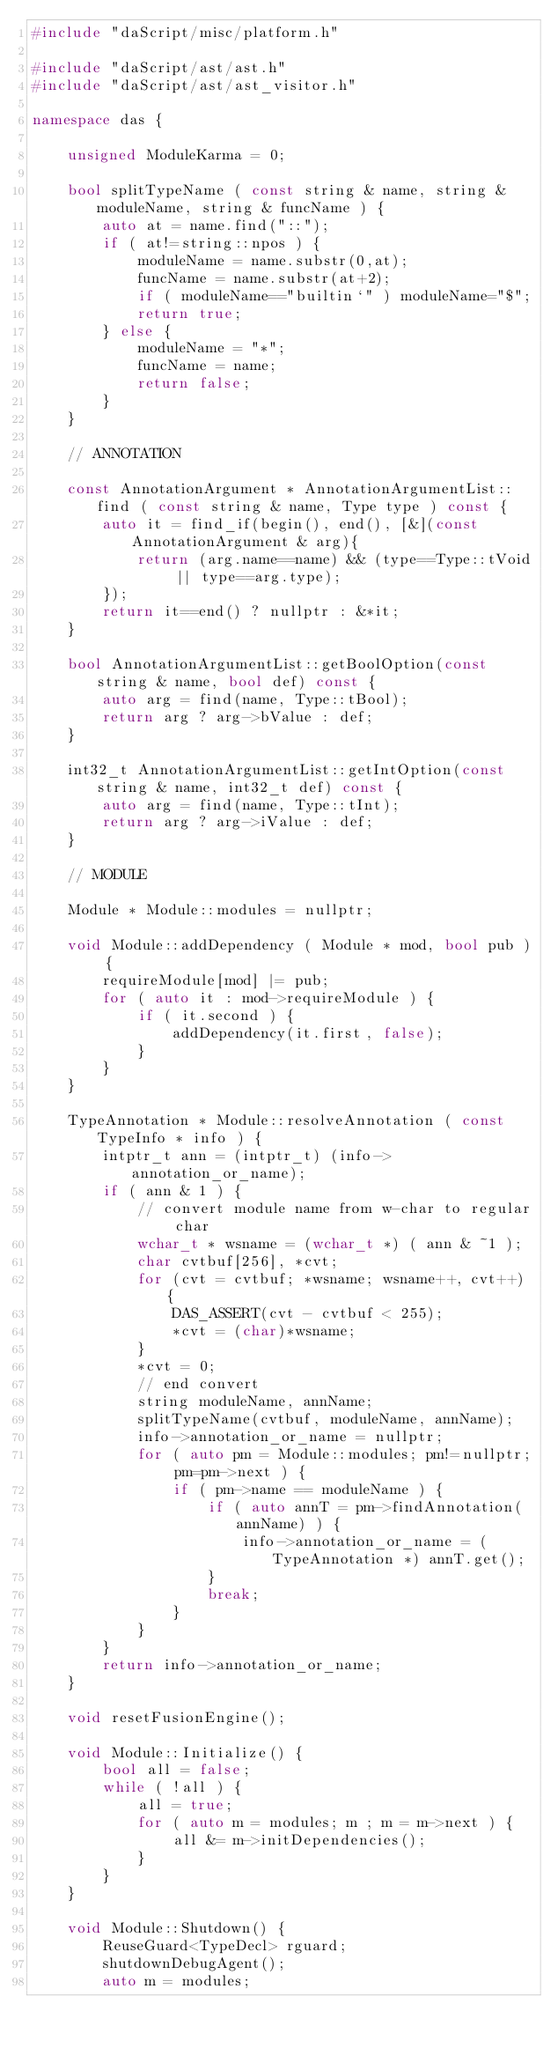Convert code to text. <code><loc_0><loc_0><loc_500><loc_500><_C++_>#include "daScript/misc/platform.h"

#include "daScript/ast/ast.h"
#include "daScript/ast/ast_visitor.h"

namespace das {

    unsigned ModuleKarma = 0;

    bool splitTypeName ( const string & name, string & moduleName, string & funcName ) {
        auto at = name.find("::");
        if ( at!=string::npos ) {
            moduleName = name.substr(0,at);
            funcName = name.substr(at+2);
            if ( moduleName=="builtin`" ) moduleName="$";
            return true;
        } else {
            moduleName = "*";
            funcName = name;
            return false;
        }
    }

    // ANNOTATION

    const AnnotationArgument * AnnotationArgumentList::find ( const string & name, Type type ) const {
        auto it = find_if(begin(), end(), [&](const AnnotationArgument & arg){
            return (arg.name==name) && (type==Type::tVoid || type==arg.type);
        });
        return it==end() ? nullptr : &*it;
    }

    bool AnnotationArgumentList::getBoolOption(const string & name, bool def) const {
        auto arg = find(name, Type::tBool);
        return arg ? arg->bValue : def;
    }

    int32_t AnnotationArgumentList::getIntOption(const string & name, int32_t def) const {
        auto arg = find(name, Type::tInt);
        return arg ? arg->iValue : def;
    }

    // MODULE

    Module * Module::modules = nullptr;

    void Module::addDependency ( Module * mod, bool pub ) {
        requireModule[mod] |= pub;
        for ( auto it : mod->requireModule ) {
            if ( it.second ) {
                addDependency(it.first, false);
            }
        }
    }

    TypeAnnotation * Module::resolveAnnotation ( const TypeInfo * info ) {
        intptr_t ann = (intptr_t) (info->annotation_or_name);
        if ( ann & 1 ) {
            // convert module name from w-char to regular char
            wchar_t * wsname = (wchar_t *) ( ann & ~1 );
            char cvtbuf[256], *cvt;
            for (cvt = cvtbuf; *wsname; wsname++, cvt++) {
                DAS_ASSERT(cvt - cvtbuf < 255);
                *cvt = (char)*wsname;
            }
            *cvt = 0;
            // end convert
            string moduleName, annName;
            splitTypeName(cvtbuf, moduleName, annName);
            info->annotation_or_name = nullptr;
            for ( auto pm = Module::modules; pm!=nullptr; pm=pm->next ) {
                if ( pm->name == moduleName ) {
                    if ( auto annT = pm->findAnnotation(annName) ) {
                        info->annotation_or_name = (TypeAnnotation *) annT.get();
                    }
                    break;
                }
            }
        }
        return info->annotation_or_name;
    }

    void resetFusionEngine();

    void Module::Initialize() {
        bool all = false;
        while ( !all ) {
            all = true;
            for ( auto m = modules; m ; m = m->next ) {
                all &= m->initDependencies();
            }
        }
    }

    void Module::Shutdown() {
        ReuseGuard<TypeDecl> rguard;
        shutdownDebugAgent();
        auto m = modules;</code> 